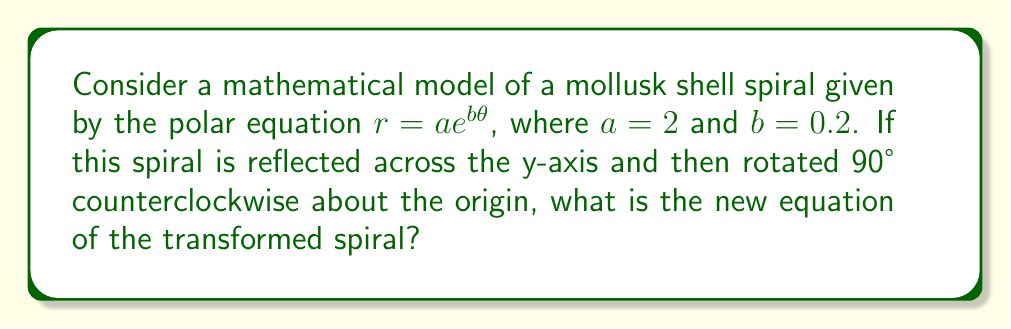Help me with this question. Let's approach this step-by-step:

1) The original equation is $r = 2e^{0.2\theta}$ in polar form.

2) Reflection across the y-axis:
   - This transforms $\theta$ to $\pi - \theta$
   - The new equation becomes $r = 2e^{0.2(\pi - \theta)} = 2e^{0.2\pi}e^{-0.2\theta}$

3) Rotation by 90° counterclockwise:
   - This adds $\frac{\pi}{2}$ to $\theta$
   - The equation becomes $r = 2e^{0.2\pi}e^{-0.2(\theta - \frac{\pi}{2})}$

4) Simplify:
   $r = 2e^{0.2\pi}e^{-0.2\theta + 0.1\pi} = 2e^{0.3\pi}e^{-0.2\theta}$

5) Calculate the constant:
   $e^{0.3\pi} \approx 2.5582$

Therefore, the final equation is approximately $r = 5.1164e^{-0.2\theta}$
Answer: $r \approx 5.1164e^{-0.2\theta}$ 